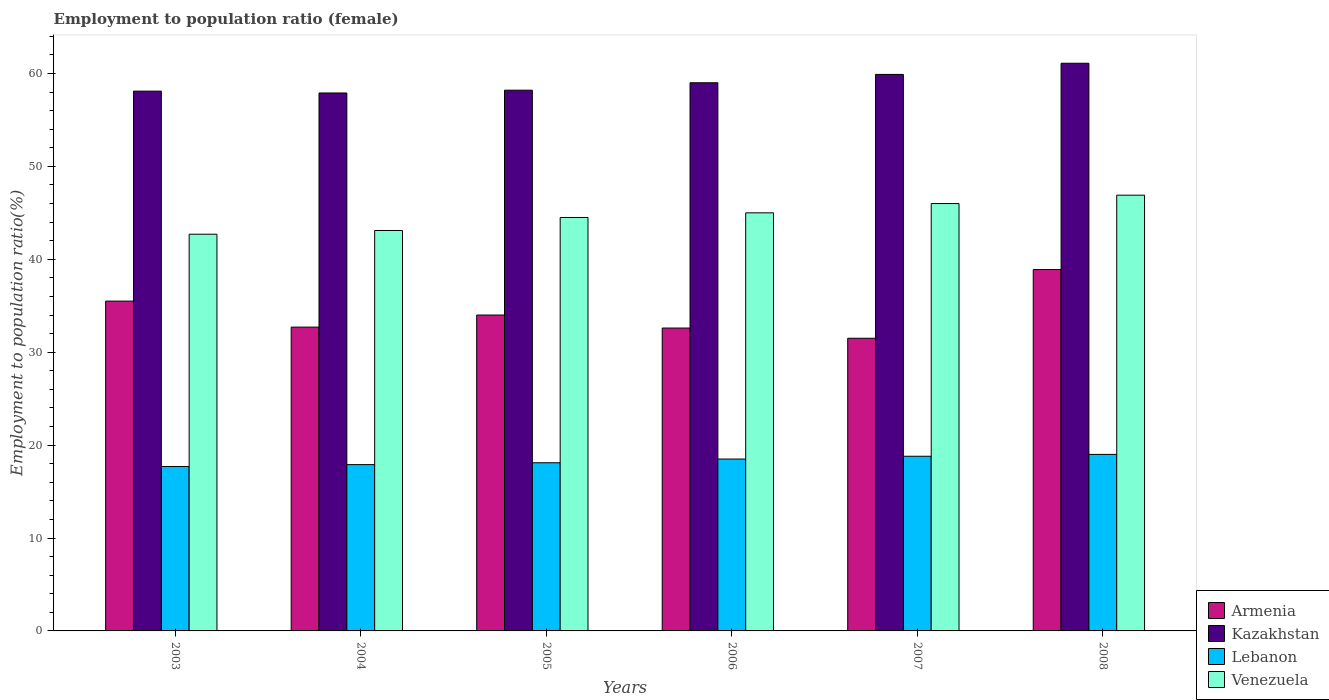How many different coloured bars are there?
Make the answer very short. 4. How many groups of bars are there?
Ensure brevity in your answer.  6. What is the employment to population ratio in Venezuela in 2004?
Keep it short and to the point. 43.1. Across all years, what is the maximum employment to population ratio in Venezuela?
Offer a very short reply. 46.9. Across all years, what is the minimum employment to population ratio in Kazakhstan?
Provide a succinct answer. 57.9. In which year was the employment to population ratio in Kazakhstan maximum?
Provide a succinct answer. 2008. In which year was the employment to population ratio in Armenia minimum?
Provide a short and direct response. 2007. What is the total employment to population ratio in Venezuela in the graph?
Your answer should be very brief. 268.2. What is the difference between the employment to population ratio in Venezuela in 2007 and that in 2008?
Offer a terse response. -0.9. What is the difference between the employment to population ratio in Kazakhstan in 2007 and the employment to population ratio in Venezuela in 2006?
Keep it short and to the point. 14.9. What is the average employment to population ratio in Armenia per year?
Provide a succinct answer. 34.2. In the year 2003, what is the difference between the employment to population ratio in Armenia and employment to population ratio in Lebanon?
Offer a terse response. 17.8. What is the ratio of the employment to population ratio in Lebanon in 2004 to that in 2006?
Provide a short and direct response. 0.97. Is the employment to population ratio in Lebanon in 2006 less than that in 2008?
Offer a very short reply. Yes. What is the difference between the highest and the second highest employment to population ratio in Lebanon?
Give a very brief answer. 0.2. What is the difference between the highest and the lowest employment to population ratio in Lebanon?
Provide a succinct answer. 1.3. In how many years, is the employment to population ratio in Armenia greater than the average employment to population ratio in Armenia taken over all years?
Your answer should be compact. 2. Is the sum of the employment to population ratio in Armenia in 2007 and 2008 greater than the maximum employment to population ratio in Venezuela across all years?
Offer a very short reply. Yes. What does the 3rd bar from the left in 2003 represents?
Provide a succinct answer. Lebanon. What does the 1st bar from the right in 2008 represents?
Your answer should be compact. Venezuela. How many bars are there?
Provide a succinct answer. 24. Are all the bars in the graph horizontal?
Keep it short and to the point. No. How many years are there in the graph?
Your response must be concise. 6. Are the values on the major ticks of Y-axis written in scientific E-notation?
Your answer should be compact. No. Where does the legend appear in the graph?
Give a very brief answer. Bottom right. How are the legend labels stacked?
Provide a short and direct response. Vertical. What is the title of the graph?
Your answer should be very brief. Employment to population ratio (female). Does "Least developed countries" appear as one of the legend labels in the graph?
Offer a terse response. No. What is the label or title of the Y-axis?
Keep it short and to the point. Employment to population ratio(%). What is the Employment to population ratio(%) in Armenia in 2003?
Ensure brevity in your answer.  35.5. What is the Employment to population ratio(%) of Kazakhstan in 2003?
Ensure brevity in your answer.  58.1. What is the Employment to population ratio(%) of Lebanon in 2003?
Make the answer very short. 17.7. What is the Employment to population ratio(%) of Venezuela in 2003?
Provide a succinct answer. 42.7. What is the Employment to population ratio(%) of Armenia in 2004?
Give a very brief answer. 32.7. What is the Employment to population ratio(%) of Kazakhstan in 2004?
Your response must be concise. 57.9. What is the Employment to population ratio(%) of Lebanon in 2004?
Your response must be concise. 17.9. What is the Employment to population ratio(%) in Venezuela in 2004?
Keep it short and to the point. 43.1. What is the Employment to population ratio(%) in Kazakhstan in 2005?
Ensure brevity in your answer.  58.2. What is the Employment to population ratio(%) of Lebanon in 2005?
Provide a short and direct response. 18.1. What is the Employment to population ratio(%) in Venezuela in 2005?
Give a very brief answer. 44.5. What is the Employment to population ratio(%) in Armenia in 2006?
Provide a succinct answer. 32.6. What is the Employment to population ratio(%) of Lebanon in 2006?
Keep it short and to the point. 18.5. What is the Employment to population ratio(%) in Venezuela in 2006?
Ensure brevity in your answer.  45. What is the Employment to population ratio(%) in Armenia in 2007?
Your answer should be compact. 31.5. What is the Employment to population ratio(%) of Kazakhstan in 2007?
Your response must be concise. 59.9. What is the Employment to population ratio(%) in Lebanon in 2007?
Make the answer very short. 18.8. What is the Employment to population ratio(%) of Armenia in 2008?
Your answer should be very brief. 38.9. What is the Employment to population ratio(%) of Kazakhstan in 2008?
Ensure brevity in your answer.  61.1. What is the Employment to population ratio(%) of Lebanon in 2008?
Make the answer very short. 19. What is the Employment to population ratio(%) of Venezuela in 2008?
Provide a short and direct response. 46.9. Across all years, what is the maximum Employment to population ratio(%) of Armenia?
Your response must be concise. 38.9. Across all years, what is the maximum Employment to population ratio(%) in Kazakhstan?
Offer a very short reply. 61.1. Across all years, what is the maximum Employment to population ratio(%) of Venezuela?
Ensure brevity in your answer.  46.9. Across all years, what is the minimum Employment to population ratio(%) of Armenia?
Offer a very short reply. 31.5. Across all years, what is the minimum Employment to population ratio(%) in Kazakhstan?
Your answer should be compact. 57.9. Across all years, what is the minimum Employment to population ratio(%) in Lebanon?
Provide a succinct answer. 17.7. Across all years, what is the minimum Employment to population ratio(%) in Venezuela?
Provide a succinct answer. 42.7. What is the total Employment to population ratio(%) of Armenia in the graph?
Your answer should be very brief. 205.2. What is the total Employment to population ratio(%) in Kazakhstan in the graph?
Give a very brief answer. 354.2. What is the total Employment to population ratio(%) in Lebanon in the graph?
Offer a very short reply. 110. What is the total Employment to population ratio(%) of Venezuela in the graph?
Keep it short and to the point. 268.2. What is the difference between the Employment to population ratio(%) of Venezuela in 2003 and that in 2004?
Ensure brevity in your answer.  -0.4. What is the difference between the Employment to population ratio(%) of Lebanon in 2003 and that in 2005?
Make the answer very short. -0.4. What is the difference between the Employment to population ratio(%) in Venezuela in 2003 and that in 2005?
Give a very brief answer. -1.8. What is the difference between the Employment to population ratio(%) of Kazakhstan in 2003 and that in 2006?
Make the answer very short. -0.9. What is the difference between the Employment to population ratio(%) of Lebanon in 2003 and that in 2006?
Your response must be concise. -0.8. What is the difference between the Employment to population ratio(%) of Venezuela in 2003 and that in 2006?
Make the answer very short. -2.3. What is the difference between the Employment to population ratio(%) of Venezuela in 2003 and that in 2007?
Your answer should be compact. -3.3. What is the difference between the Employment to population ratio(%) of Armenia in 2003 and that in 2008?
Offer a terse response. -3.4. What is the difference between the Employment to population ratio(%) of Kazakhstan in 2003 and that in 2008?
Provide a short and direct response. -3. What is the difference between the Employment to population ratio(%) of Lebanon in 2004 and that in 2005?
Ensure brevity in your answer.  -0.2. What is the difference between the Employment to population ratio(%) in Venezuela in 2004 and that in 2005?
Your answer should be very brief. -1.4. What is the difference between the Employment to population ratio(%) in Kazakhstan in 2004 and that in 2007?
Provide a short and direct response. -2. What is the difference between the Employment to population ratio(%) of Lebanon in 2004 and that in 2007?
Give a very brief answer. -0.9. What is the difference between the Employment to population ratio(%) in Venezuela in 2004 and that in 2007?
Ensure brevity in your answer.  -2.9. What is the difference between the Employment to population ratio(%) in Kazakhstan in 2004 and that in 2008?
Provide a succinct answer. -3.2. What is the difference between the Employment to population ratio(%) of Lebanon in 2004 and that in 2008?
Make the answer very short. -1.1. What is the difference between the Employment to population ratio(%) in Venezuela in 2004 and that in 2008?
Provide a succinct answer. -3.8. What is the difference between the Employment to population ratio(%) in Armenia in 2005 and that in 2006?
Give a very brief answer. 1.4. What is the difference between the Employment to population ratio(%) in Lebanon in 2005 and that in 2006?
Offer a terse response. -0.4. What is the difference between the Employment to population ratio(%) in Venezuela in 2005 and that in 2006?
Your answer should be compact. -0.5. What is the difference between the Employment to population ratio(%) in Venezuela in 2005 and that in 2008?
Offer a very short reply. -2.4. What is the difference between the Employment to population ratio(%) of Venezuela in 2006 and that in 2007?
Make the answer very short. -1. What is the difference between the Employment to population ratio(%) in Kazakhstan in 2006 and that in 2008?
Offer a terse response. -2.1. What is the difference between the Employment to population ratio(%) of Armenia in 2007 and that in 2008?
Your answer should be very brief. -7.4. What is the difference between the Employment to population ratio(%) of Kazakhstan in 2007 and that in 2008?
Make the answer very short. -1.2. What is the difference between the Employment to population ratio(%) of Lebanon in 2007 and that in 2008?
Ensure brevity in your answer.  -0.2. What is the difference between the Employment to population ratio(%) in Venezuela in 2007 and that in 2008?
Ensure brevity in your answer.  -0.9. What is the difference between the Employment to population ratio(%) of Armenia in 2003 and the Employment to population ratio(%) of Kazakhstan in 2004?
Your response must be concise. -22.4. What is the difference between the Employment to population ratio(%) of Kazakhstan in 2003 and the Employment to population ratio(%) of Lebanon in 2004?
Keep it short and to the point. 40.2. What is the difference between the Employment to population ratio(%) of Lebanon in 2003 and the Employment to population ratio(%) of Venezuela in 2004?
Ensure brevity in your answer.  -25.4. What is the difference between the Employment to population ratio(%) of Armenia in 2003 and the Employment to population ratio(%) of Kazakhstan in 2005?
Make the answer very short. -22.7. What is the difference between the Employment to population ratio(%) of Kazakhstan in 2003 and the Employment to population ratio(%) of Lebanon in 2005?
Your answer should be compact. 40. What is the difference between the Employment to population ratio(%) in Lebanon in 2003 and the Employment to population ratio(%) in Venezuela in 2005?
Make the answer very short. -26.8. What is the difference between the Employment to population ratio(%) in Armenia in 2003 and the Employment to population ratio(%) in Kazakhstan in 2006?
Make the answer very short. -23.5. What is the difference between the Employment to population ratio(%) in Armenia in 2003 and the Employment to population ratio(%) in Venezuela in 2006?
Ensure brevity in your answer.  -9.5. What is the difference between the Employment to population ratio(%) of Kazakhstan in 2003 and the Employment to population ratio(%) of Lebanon in 2006?
Your answer should be very brief. 39.6. What is the difference between the Employment to population ratio(%) in Lebanon in 2003 and the Employment to population ratio(%) in Venezuela in 2006?
Ensure brevity in your answer.  -27.3. What is the difference between the Employment to population ratio(%) in Armenia in 2003 and the Employment to population ratio(%) in Kazakhstan in 2007?
Your answer should be compact. -24.4. What is the difference between the Employment to population ratio(%) of Armenia in 2003 and the Employment to population ratio(%) of Venezuela in 2007?
Make the answer very short. -10.5. What is the difference between the Employment to population ratio(%) of Kazakhstan in 2003 and the Employment to population ratio(%) of Lebanon in 2007?
Provide a succinct answer. 39.3. What is the difference between the Employment to population ratio(%) of Kazakhstan in 2003 and the Employment to population ratio(%) of Venezuela in 2007?
Make the answer very short. 12.1. What is the difference between the Employment to population ratio(%) in Lebanon in 2003 and the Employment to population ratio(%) in Venezuela in 2007?
Provide a succinct answer. -28.3. What is the difference between the Employment to population ratio(%) of Armenia in 2003 and the Employment to population ratio(%) of Kazakhstan in 2008?
Provide a succinct answer. -25.6. What is the difference between the Employment to population ratio(%) of Armenia in 2003 and the Employment to population ratio(%) of Lebanon in 2008?
Ensure brevity in your answer.  16.5. What is the difference between the Employment to population ratio(%) of Armenia in 2003 and the Employment to population ratio(%) of Venezuela in 2008?
Your response must be concise. -11.4. What is the difference between the Employment to population ratio(%) in Kazakhstan in 2003 and the Employment to population ratio(%) in Lebanon in 2008?
Your response must be concise. 39.1. What is the difference between the Employment to population ratio(%) of Lebanon in 2003 and the Employment to population ratio(%) of Venezuela in 2008?
Keep it short and to the point. -29.2. What is the difference between the Employment to population ratio(%) of Armenia in 2004 and the Employment to population ratio(%) of Kazakhstan in 2005?
Provide a short and direct response. -25.5. What is the difference between the Employment to population ratio(%) in Kazakhstan in 2004 and the Employment to population ratio(%) in Lebanon in 2005?
Keep it short and to the point. 39.8. What is the difference between the Employment to population ratio(%) of Kazakhstan in 2004 and the Employment to population ratio(%) of Venezuela in 2005?
Make the answer very short. 13.4. What is the difference between the Employment to population ratio(%) in Lebanon in 2004 and the Employment to population ratio(%) in Venezuela in 2005?
Keep it short and to the point. -26.6. What is the difference between the Employment to population ratio(%) in Armenia in 2004 and the Employment to population ratio(%) in Kazakhstan in 2006?
Give a very brief answer. -26.3. What is the difference between the Employment to population ratio(%) of Armenia in 2004 and the Employment to population ratio(%) of Lebanon in 2006?
Your response must be concise. 14.2. What is the difference between the Employment to population ratio(%) of Kazakhstan in 2004 and the Employment to population ratio(%) of Lebanon in 2006?
Provide a short and direct response. 39.4. What is the difference between the Employment to population ratio(%) in Kazakhstan in 2004 and the Employment to population ratio(%) in Venezuela in 2006?
Ensure brevity in your answer.  12.9. What is the difference between the Employment to population ratio(%) of Lebanon in 2004 and the Employment to population ratio(%) of Venezuela in 2006?
Provide a succinct answer. -27.1. What is the difference between the Employment to population ratio(%) of Armenia in 2004 and the Employment to population ratio(%) of Kazakhstan in 2007?
Your answer should be very brief. -27.2. What is the difference between the Employment to population ratio(%) in Kazakhstan in 2004 and the Employment to population ratio(%) in Lebanon in 2007?
Ensure brevity in your answer.  39.1. What is the difference between the Employment to population ratio(%) in Lebanon in 2004 and the Employment to population ratio(%) in Venezuela in 2007?
Make the answer very short. -28.1. What is the difference between the Employment to population ratio(%) in Armenia in 2004 and the Employment to population ratio(%) in Kazakhstan in 2008?
Keep it short and to the point. -28.4. What is the difference between the Employment to population ratio(%) in Kazakhstan in 2004 and the Employment to population ratio(%) in Lebanon in 2008?
Your response must be concise. 38.9. What is the difference between the Employment to population ratio(%) in Lebanon in 2004 and the Employment to population ratio(%) in Venezuela in 2008?
Give a very brief answer. -29. What is the difference between the Employment to population ratio(%) of Armenia in 2005 and the Employment to population ratio(%) of Lebanon in 2006?
Offer a very short reply. 15.5. What is the difference between the Employment to population ratio(%) in Kazakhstan in 2005 and the Employment to population ratio(%) in Lebanon in 2006?
Make the answer very short. 39.7. What is the difference between the Employment to population ratio(%) of Kazakhstan in 2005 and the Employment to population ratio(%) of Venezuela in 2006?
Provide a short and direct response. 13.2. What is the difference between the Employment to population ratio(%) of Lebanon in 2005 and the Employment to population ratio(%) of Venezuela in 2006?
Keep it short and to the point. -26.9. What is the difference between the Employment to population ratio(%) in Armenia in 2005 and the Employment to population ratio(%) in Kazakhstan in 2007?
Ensure brevity in your answer.  -25.9. What is the difference between the Employment to population ratio(%) in Armenia in 2005 and the Employment to population ratio(%) in Lebanon in 2007?
Keep it short and to the point. 15.2. What is the difference between the Employment to population ratio(%) in Kazakhstan in 2005 and the Employment to population ratio(%) in Lebanon in 2007?
Make the answer very short. 39.4. What is the difference between the Employment to population ratio(%) in Kazakhstan in 2005 and the Employment to population ratio(%) in Venezuela in 2007?
Your answer should be compact. 12.2. What is the difference between the Employment to population ratio(%) in Lebanon in 2005 and the Employment to population ratio(%) in Venezuela in 2007?
Make the answer very short. -27.9. What is the difference between the Employment to population ratio(%) of Armenia in 2005 and the Employment to population ratio(%) of Kazakhstan in 2008?
Provide a succinct answer. -27.1. What is the difference between the Employment to population ratio(%) of Armenia in 2005 and the Employment to population ratio(%) of Lebanon in 2008?
Your answer should be compact. 15. What is the difference between the Employment to population ratio(%) in Armenia in 2005 and the Employment to population ratio(%) in Venezuela in 2008?
Your answer should be compact. -12.9. What is the difference between the Employment to population ratio(%) of Kazakhstan in 2005 and the Employment to population ratio(%) of Lebanon in 2008?
Provide a succinct answer. 39.2. What is the difference between the Employment to population ratio(%) of Lebanon in 2005 and the Employment to population ratio(%) of Venezuela in 2008?
Give a very brief answer. -28.8. What is the difference between the Employment to population ratio(%) in Armenia in 2006 and the Employment to population ratio(%) in Kazakhstan in 2007?
Keep it short and to the point. -27.3. What is the difference between the Employment to population ratio(%) in Armenia in 2006 and the Employment to population ratio(%) in Lebanon in 2007?
Ensure brevity in your answer.  13.8. What is the difference between the Employment to population ratio(%) of Armenia in 2006 and the Employment to population ratio(%) of Venezuela in 2007?
Keep it short and to the point. -13.4. What is the difference between the Employment to population ratio(%) of Kazakhstan in 2006 and the Employment to population ratio(%) of Lebanon in 2007?
Keep it short and to the point. 40.2. What is the difference between the Employment to population ratio(%) of Lebanon in 2006 and the Employment to population ratio(%) of Venezuela in 2007?
Your answer should be compact. -27.5. What is the difference between the Employment to population ratio(%) in Armenia in 2006 and the Employment to population ratio(%) in Kazakhstan in 2008?
Provide a succinct answer. -28.5. What is the difference between the Employment to population ratio(%) in Armenia in 2006 and the Employment to population ratio(%) in Venezuela in 2008?
Give a very brief answer. -14.3. What is the difference between the Employment to population ratio(%) of Kazakhstan in 2006 and the Employment to population ratio(%) of Venezuela in 2008?
Ensure brevity in your answer.  12.1. What is the difference between the Employment to population ratio(%) in Lebanon in 2006 and the Employment to population ratio(%) in Venezuela in 2008?
Make the answer very short. -28.4. What is the difference between the Employment to population ratio(%) of Armenia in 2007 and the Employment to population ratio(%) of Kazakhstan in 2008?
Your response must be concise. -29.6. What is the difference between the Employment to population ratio(%) of Armenia in 2007 and the Employment to population ratio(%) of Lebanon in 2008?
Ensure brevity in your answer.  12.5. What is the difference between the Employment to population ratio(%) in Armenia in 2007 and the Employment to population ratio(%) in Venezuela in 2008?
Offer a very short reply. -15.4. What is the difference between the Employment to population ratio(%) in Kazakhstan in 2007 and the Employment to population ratio(%) in Lebanon in 2008?
Give a very brief answer. 40.9. What is the difference between the Employment to population ratio(%) in Lebanon in 2007 and the Employment to population ratio(%) in Venezuela in 2008?
Provide a short and direct response. -28.1. What is the average Employment to population ratio(%) in Armenia per year?
Offer a very short reply. 34.2. What is the average Employment to population ratio(%) in Kazakhstan per year?
Offer a terse response. 59.03. What is the average Employment to population ratio(%) of Lebanon per year?
Make the answer very short. 18.33. What is the average Employment to population ratio(%) of Venezuela per year?
Give a very brief answer. 44.7. In the year 2003, what is the difference between the Employment to population ratio(%) of Armenia and Employment to population ratio(%) of Kazakhstan?
Ensure brevity in your answer.  -22.6. In the year 2003, what is the difference between the Employment to population ratio(%) in Armenia and Employment to population ratio(%) in Lebanon?
Make the answer very short. 17.8. In the year 2003, what is the difference between the Employment to population ratio(%) in Kazakhstan and Employment to population ratio(%) in Lebanon?
Offer a terse response. 40.4. In the year 2004, what is the difference between the Employment to population ratio(%) of Armenia and Employment to population ratio(%) of Kazakhstan?
Make the answer very short. -25.2. In the year 2004, what is the difference between the Employment to population ratio(%) of Armenia and Employment to population ratio(%) of Venezuela?
Ensure brevity in your answer.  -10.4. In the year 2004, what is the difference between the Employment to population ratio(%) of Kazakhstan and Employment to population ratio(%) of Lebanon?
Provide a succinct answer. 40. In the year 2004, what is the difference between the Employment to population ratio(%) of Kazakhstan and Employment to population ratio(%) of Venezuela?
Provide a short and direct response. 14.8. In the year 2004, what is the difference between the Employment to population ratio(%) in Lebanon and Employment to population ratio(%) in Venezuela?
Your response must be concise. -25.2. In the year 2005, what is the difference between the Employment to population ratio(%) of Armenia and Employment to population ratio(%) of Kazakhstan?
Provide a short and direct response. -24.2. In the year 2005, what is the difference between the Employment to population ratio(%) of Armenia and Employment to population ratio(%) of Lebanon?
Make the answer very short. 15.9. In the year 2005, what is the difference between the Employment to population ratio(%) in Kazakhstan and Employment to population ratio(%) in Lebanon?
Make the answer very short. 40.1. In the year 2005, what is the difference between the Employment to population ratio(%) in Kazakhstan and Employment to population ratio(%) in Venezuela?
Your response must be concise. 13.7. In the year 2005, what is the difference between the Employment to population ratio(%) in Lebanon and Employment to population ratio(%) in Venezuela?
Provide a succinct answer. -26.4. In the year 2006, what is the difference between the Employment to population ratio(%) of Armenia and Employment to population ratio(%) of Kazakhstan?
Your answer should be compact. -26.4. In the year 2006, what is the difference between the Employment to population ratio(%) of Armenia and Employment to population ratio(%) of Venezuela?
Offer a very short reply. -12.4. In the year 2006, what is the difference between the Employment to population ratio(%) in Kazakhstan and Employment to population ratio(%) in Lebanon?
Your response must be concise. 40.5. In the year 2006, what is the difference between the Employment to population ratio(%) of Lebanon and Employment to population ratio(%) of Venezuela?
Your response must be concise. -26.5. In the year 2007, what is the difference between the Employment to population ratio(%) in Armenia and Employment to population ratio(%) in Kazakhstan?
Keep it short and to the point. -28.4. In the year 2007, what is the difference between the Employment to population ratio(%) in Armenia and Employment to population ratio(%) in Lebanon?
Offer a very short reply. 12.7. In the year 2007, what is the difference between the Employment to population ratio(%) in Armenia and Employment to population ratio(%) in Venezuela?
Keep it short and to the point. -14.5. In the year 2007, what is the difference between the Employment to population ratio(%) in Kazakhstan and Employment to population ratio(%) in Lebanon?
Give a very brief answer. 41.1. In the year 2007, what is the difference between the Employment to population ratio(%) in Lebanon and Employment to population ratio(%) in Venezuela?
Your answer should be very brief. -27.2. In the year 2008, what is the difference between the Employment to population ratio(%) of Armenia and Employment to population ratio(%) of Kazakhstan?
Provide a short and direct response. -22.2. In the year 2008, what is the difference between the Employment to population ratio(%) in Kazakhstan and Employment to population ratio(%) in Lebanon?
Your response must be concise. 42.1. In the year 2008, what is the difference between the Employment to population ratio(%) of Kazakhstan and Employment to population ratio(%) of Venezuela?
Provide a succinct answer. 14.2. In the year 2008, what is the difference between the Employment to population ratio(%) of Lebanon and Employment to population ratio(%) of Venezuela?
Offer a terse response. -27.9. What is the ratio of the Employment to population ratio(%) of Armenia in 2003 to that in 2004?
Your response must be concise. 1.09. What is the ratio of the Employment to population ratio(%) in Venezuela in 2003 to that in 2004?
Make the answer very short. 0.99. What is the ratio of the Employment to population ratio(%) of Armenia in 2003 to that in 2005?
Offer a terse response. 1.04. What is the ratio of the Employment to population ratio(%) in Kazakhstan in 2003 to that in 2005?
Offer a terse response. 1. What is the ratio of the Employment to population ratio(%) of Lebanon in 2003 to that in 2005?
Offer a very short reply. 0.98. What is the ratio of the Employment to population ratio(%) of Venezuela in 2003 to that in 2005?
Offer a terse response. 0.96. What is the ratio of the Employment to population ratio(%) of Armenia in 2003 to that in 2006?
Provide a succinct answer. 1.09. What is the ratio of the Employment to population ratio(%) of Kazakhstan in 2003 to that in 2006?
Ensure brevity in your answer.  0.98. What is the ratio of the Employment to population ratio(%) of Lebanon in 2003 to that in 2006?
Your answer should be compact. 0.96. What is the ratio of the Employment to population ratio(%) in Venezuela in 2003 to that in 2006?
Your response must be concise. 0.95. What is the ratio of the Employment to population ratio(%) of Armenia in 2003 to that in 2007?
Keep it short and to the point. 1.13. What is the ratio of the Employment to population ratio(%) in Kazakhstan in 2003 to that in 2007?
Keep it short and to the point. 0.97. What is the ratio of the Employment to population ratio(%) in Lebanon in 2003 to that in 2007?
Offer a terse response. 0.94. What is the ratio of the Employment to population ratio(%) in Venezuela in 2003 to that in 2007?
Ensure brevity in your answer.  0.93. What is the ratio of the Employment to population ratio(%) of Armenia in 2003 to that in 2008?
Keep it short and to the point. 0.91. What is the ratio of the Employment to population ratio(%) of Kazakhstan in 2003 to that in 2008?
Ensure brevity in your answer.  0.95. What is the ratio of the Employment to population ratio(%) in Lebanon in 2003 to that in 2008?
Your answer should be compact. 0.93. What is the ratio of the Employment to population ratio(%) of Venezuela in 2003 to that in 2008?
Provide a succinct answer. 0.91. What is the ratio of the Employment to population ratio(%) of Armenia in 2004 to that in 2005?
Give a very brief answer. 0.96. What is the ratio of the Employment to population ratio(%) of Kazakhstan in 2004 to that in 2005?
Ensure brevity in your answer.  0.99. What is the ratio of the Employment to population ratio(%) of Venezuela in 2004 to that in 2005?
Provide a succinct answer. 0.97. What is the ratio of the Employment to population ratio(%) in Armenia in 2004 to that in 2006?
Offer a terse response. 1. What is the ratio of the Employment to population ratio(%) of Kazakhstan in 2004 to that in 2006?
Provide a succinct answer. 0.98. What is the ratio of the Employment to population ratio(%) in Lebanon in 2004 to that in 2006?
Provide a succinct answer. 0.97. What is the ratio of the Employment to population ratio(%) in Venezuela in 2004 to that in 2006?
Provide a short and direct response. 0.96. What is the ratio of the Employment to population ratio(%) of Armenia in 2004 to that in 2007?
Provide a short and direct response. 1.04. What is the ratio of the Employment to population ratio(%) of Kazakhstan in 2004 to that in 2007?
Provide a short and direct response. 0.97. What is the ratio of the Employment to population ratio(%) of Lebanon in 2004 to that in 2007?
Your answer should be compact. 0.95. What is the ratio of the Employment to population ratio(%) in Venezuela in 2004 to that in 2007?
Your response must be concise. 0.94. What is the ratio of the Employment to population ratio(%) in Armenia in 2004 to that in 2008?
Your answer should be compact. 0.84. What is the ratio of the Employment to population ratio(%) in Kazakhstan in 2004 to that in 2008?
Your response must be concise. 0.95. What is the ratio of the Employment to population ratio(%) of Lebanon in 2004 to that in 2008?
Your answer should be compact. 0.94. What is the ratio of the Employment to population ratio(%) in Venezuela in 2004 to that in 2008?
Make the answer very short. 0.92. What is the ratio of the Employment to population ratio(%) in Armenia in 2005 to that in 2006?
Your answer should be very brief. 1.04. What is the ratio of the Employment to population ratio(%) in Kazakhstan in 2005 to that in 2006?
Offer a very short reply. 0.99. What is the ratio of the Employment to population ratio(%) of Lebanon in 2005 to that in 2006?
Provide a succinct answer. 0.98. What is the ratio of the Employment to population ratio(%) in Venezuela in 2005 to that in 2006?
Make the answer very short. 0.99. What is the ratio of the Employment to population ratio(%) in Armenia in 2005 to that in 2007?
Your answer should be very brief. 1.08. What is the ratio of the Employment to population ratio(%) in Kazakhstan in 2005 to that in 2007?
Give a very brief answer. 0.97. What is the ratio of the Employment to population ratio(%) in Lebanon in 2005 to that in 2007?
Provide a succinct answer. 0.96. What is the ratio of the Employment to population ratio(%) of Venezuela in 2005 to that in 2007?
Give a very brief answer. 0.97. What is the ratio of the Employment to population ratio(%) in Armenia in 2005 to that in 2008?
Your response must be concise. 0.87. What is the ratio of the Employment to population ratio(%) in Kazakhstan in 2005 to that in 2008?
Make the answer very short. 0.95. What is the ratio of the Employment to population ratio(%) of Lebanon in 2005 to that in 2008?
Provide a short and direct response. 0.95. What is the ratio of the Employment to population ratio(%) of Venezuela in 2005 to that in 2008?
Offer a very short reply. 0.95. What is the ratio of the Employment to population ratio(%) of Armenia in 2006 to that in 2007?
Provide a short and direct response. 1.03. What is the ratio of the Employment to population ratio(%) of Kazakhstan in 2006 to that in 2007?
Provide a short and direct response. 0.98. What is the ratio of the Employment to population ratio(%) of Lebanon in 2006 to that in 2007?
Your response must be concise. 0.98. What is the ratio of the Employment to population ratio(%) of Venezuela in 2006 to that in 2007?
Ensure brevity in your answer.  0.98. What is the ratio of the Employment to population ratio(%) in Armenia in 2006 to that in 2008?
Offer a terse response. 0.84. What is the ratio of the Employment to population ratio(%) of Kazakhstan in 2006 to that in 2008?
Ensure brevity in your answer.  0.97. What is the ratio of the Employment to population ratio(%) in Lebanon in 2006 to that in 2008?
Provide a succinct answer. 0.97. What is the ratio of the Employment to population ratio(%) in Venezuela in 2006 to that in 2008?
Give a very brief answer. 0.96. What is the ratio of the Employment to population ratio(%) in Armenia in 2007 to that in 2008?
Keep it short and to the point. 0.81. What is the ratio of the Employment to population ratio(%) in Kazakhstan in 2007 to that in 2008?
Provide a succinct answer. 0.98. What is the ratio of the Employment to population ratio(%) of Venezuela in 2007 to that in 2008?
Offer a very short reply. 0.98. What is the difference between the highest and the second highest Employment to population ratio(%) in Armenia?
Make the answer very short. 3.4. What is the difference between the highest and the second highest Employment to population ratio(%) of Kazakhstan?
Ensure brevity in your answer.  1.2. What is the difference between the highest and the second highest Employment to population ratio(%) of Lebanon?
Your answer should be very brief. 0.2. What is the difference between the highest and the second highest Employment to population ratio(%) of Venezuela?
Your response must be concise. 0.9. What is the difference between the highest and the lowest Employment to population ratio(%) in Armenia?
Your response must be concise. 7.4. What is the difference between the highest and the lowest Employment to population ratio(%) in Venezuela?
Keep it short and to the point. 4.2. 